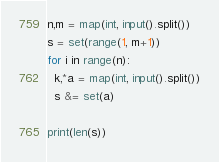Convert code to text. <code><loc_0><loc_0><loc_500><loc_500><_Python_>n,m = map(int, input().split())
s = set(range(1, m+1))
for i in range(n):
  k,*a = map(int, input().split())
  s &= set(a)
  
print(len(s))</code> 